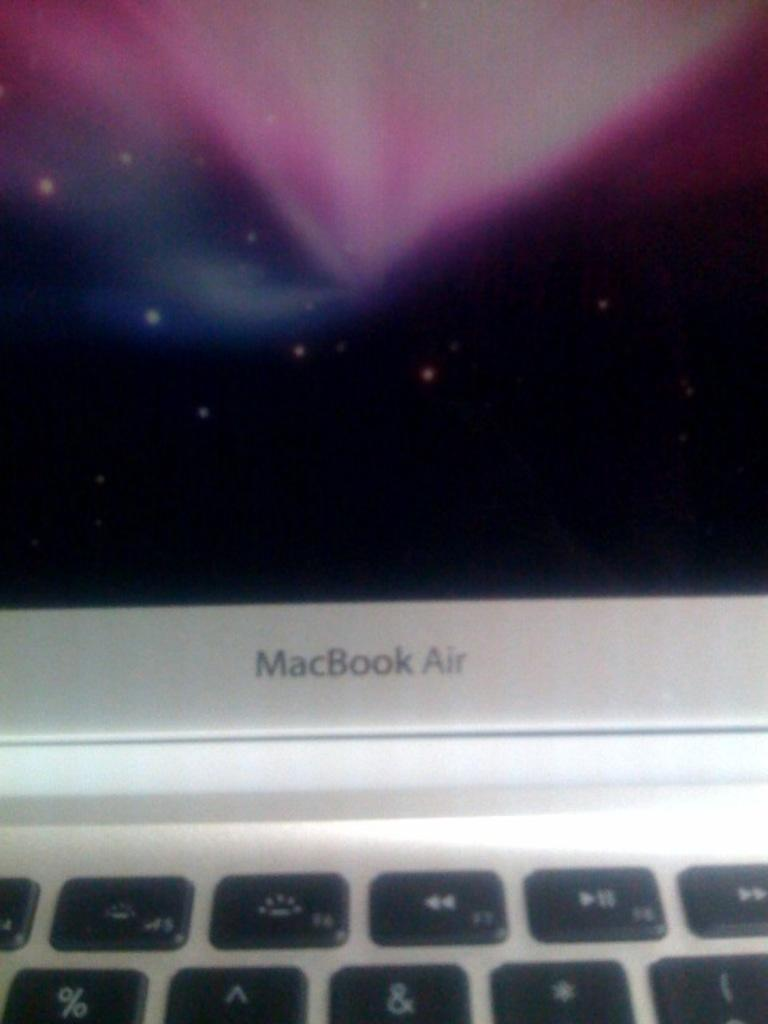<image>
Write a terse but informative summary of the picture. A close up of a MacBook Air computer, the display has a screen saver. 